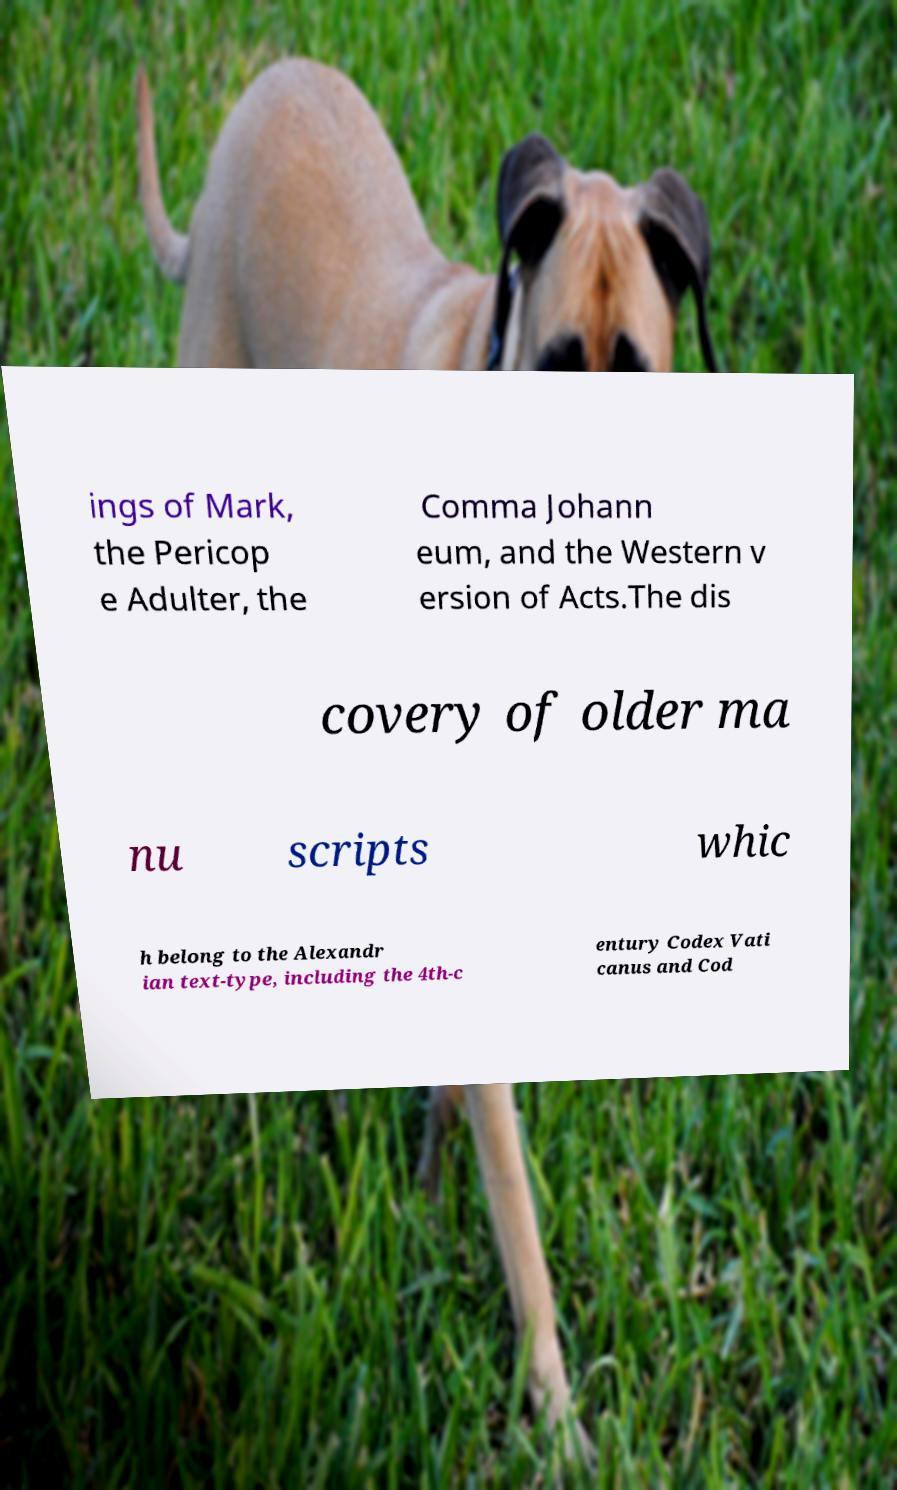Please read and relay the text visible in this image. What does it say? ings of Mark, the Pericop e Adulter, the Comma Johann eum, and the Western v ersion of Acts.The dis covery of older ma nu scripts whic h belong to the Alexandr ian text-type, including the 4th-c entury Codex Vati canus and Cod 